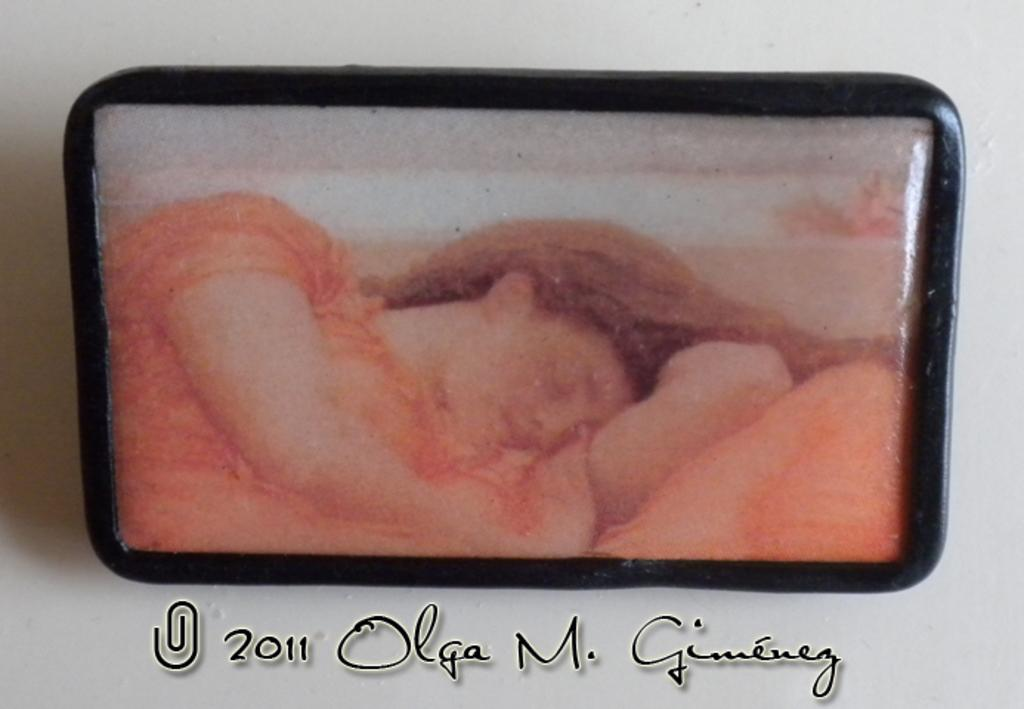What can be seen hanging on the wall in the image? There is a photo frame on the wall in the image. Is there any text present in the image? Yes, there is text at the bottom of the image. What type of government is depicted in the image? There is no depiction of a government in the image; it only features a photo frame and text. How can you tell if the room in the image is quiet? The image does not provide any information about the noise level in the room. 